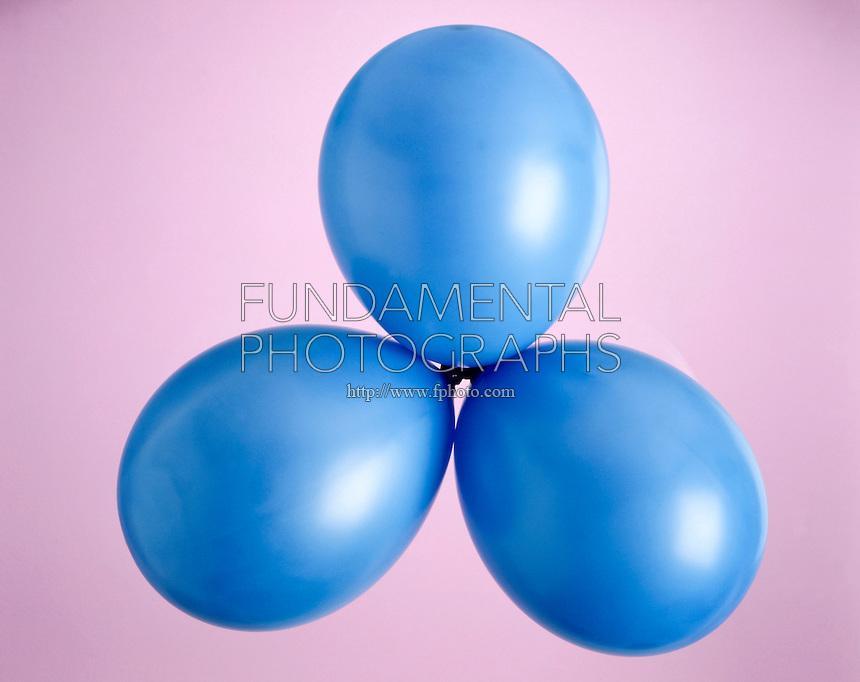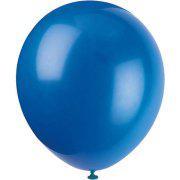The first image is the image on the left, the second image is the image on the right. Considering the images on both sides, is "There are no more than three balloons in each image." valid? Answer yes or no. Yes. The first image is the image on the left, the second image is the image on the right. Evaluate the accuracy of this statement regarding the images: "AN image shows at least three blue balloons displayed with knot ends joined at the center.". Is it true? Answer yes or no. Yes. 